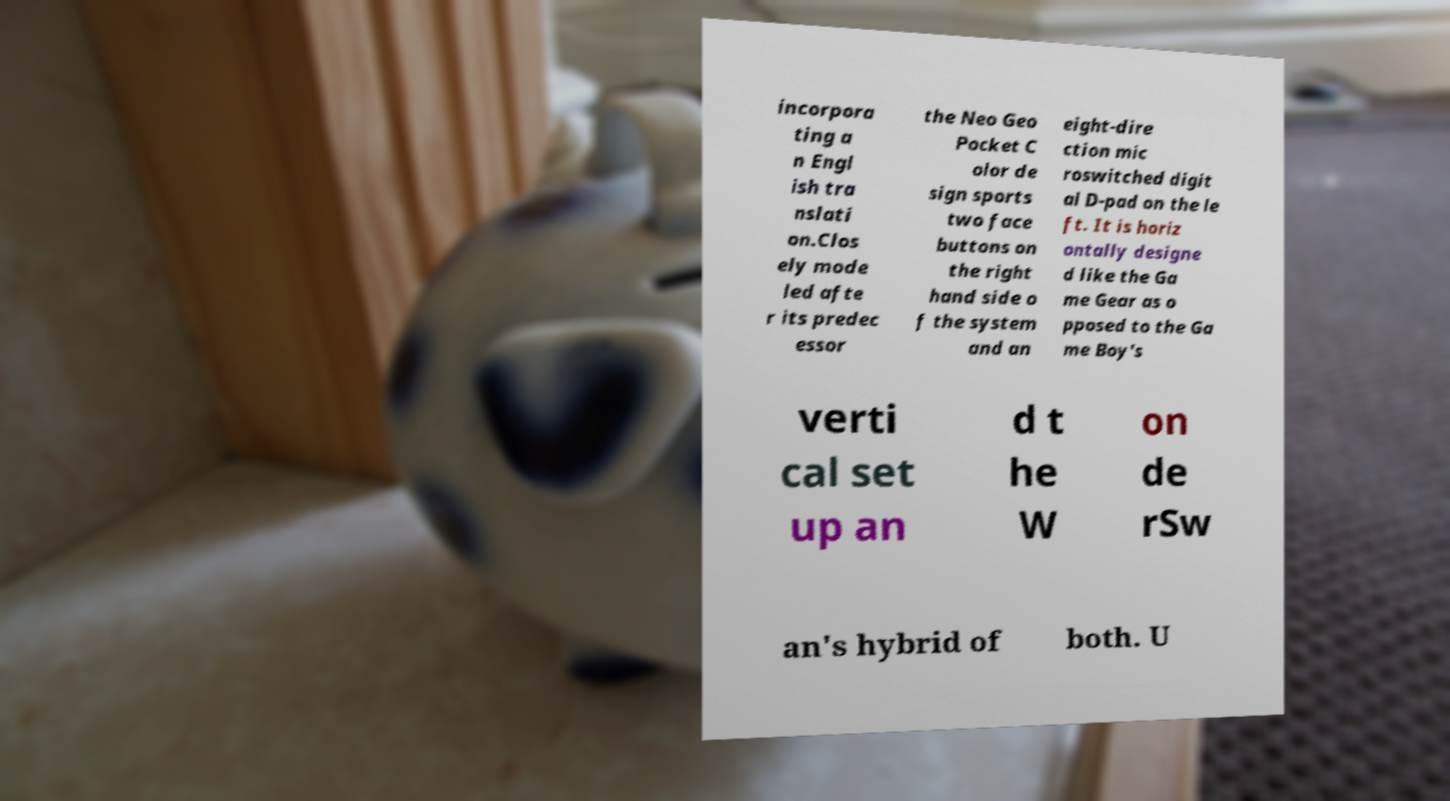Can you accurately transcribe the text from the provided image for me? incorpora ting a n Engl ish tra nslati on.Clos ely mode led afte r its predec essor the Neo Geo Pocket C olor de sign sports two face buttons on the right hand side o f the system and an eight-dire ction mic roswitched digit al D-pad on the le ft. It is horiz ontally designe d like the Ga me Gear as o pposed to the Ga me Boy's verti cal set up an d t he W on de rSw an's hybrid of both. U 